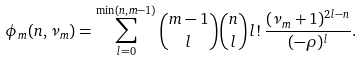Convert formula to latex. <formula><loc_0><loc_0><loc_500><loc_500>\phi _ { m } ( n , \nu _ { m } ) = \sum _ { l = 0 } ^ { \min ( n , m - 1 ) } \binom { m - 1 } { l } \binom { n } { l } \, l ! \, \frac { ( \nu _ { m } + 1 ) ^ { 2 l - n } } { ( - \rho ) ^ { l } } .</formula> 